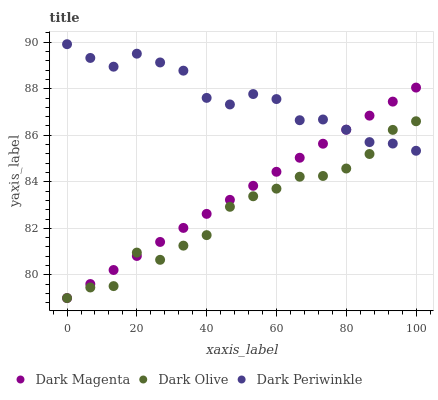Does Dark Olive have the minimum area under the curve?
Answer yes or no. Yes. Does Dark Periwinkle have the maximum area under the curve?
Answer yes or no. Yes. Does Dark Magenta have the minimum area under the curve?
Answer yes or no. No. Does Dark Magenta have the maximum area under the curve?
Answer yes or no. No. Is Dark Magenta the smoothest?
Answer yes or no. Yes. Is Dark Olive the roughest?
Answer yes or no. Yes. Is Dark Periwinkle the smoothest?
Answer yes or no. No. Is Dark Periwinkle the roughest?
Answer yes or no. No. Does Dark Olive have the lowest value?
Answer yes or no. Yes. Does Dark Periwinkle have the lowest value?
Answer yes or no. No. Does Dark Periwinkle have the highest value?
Answer yes or no. Yes. Does Dark Magenta have the highest value?
Answer yes or no. No. Does Dark Olive intersect Dark Periwinkle?
Answer yes or no. Yes. Is Dark Olive less than Dark Periwinkle?
Answer yes or no. No. Is Dark Olive greater than Dark Periwinkle?
Answer yes or no. No. 